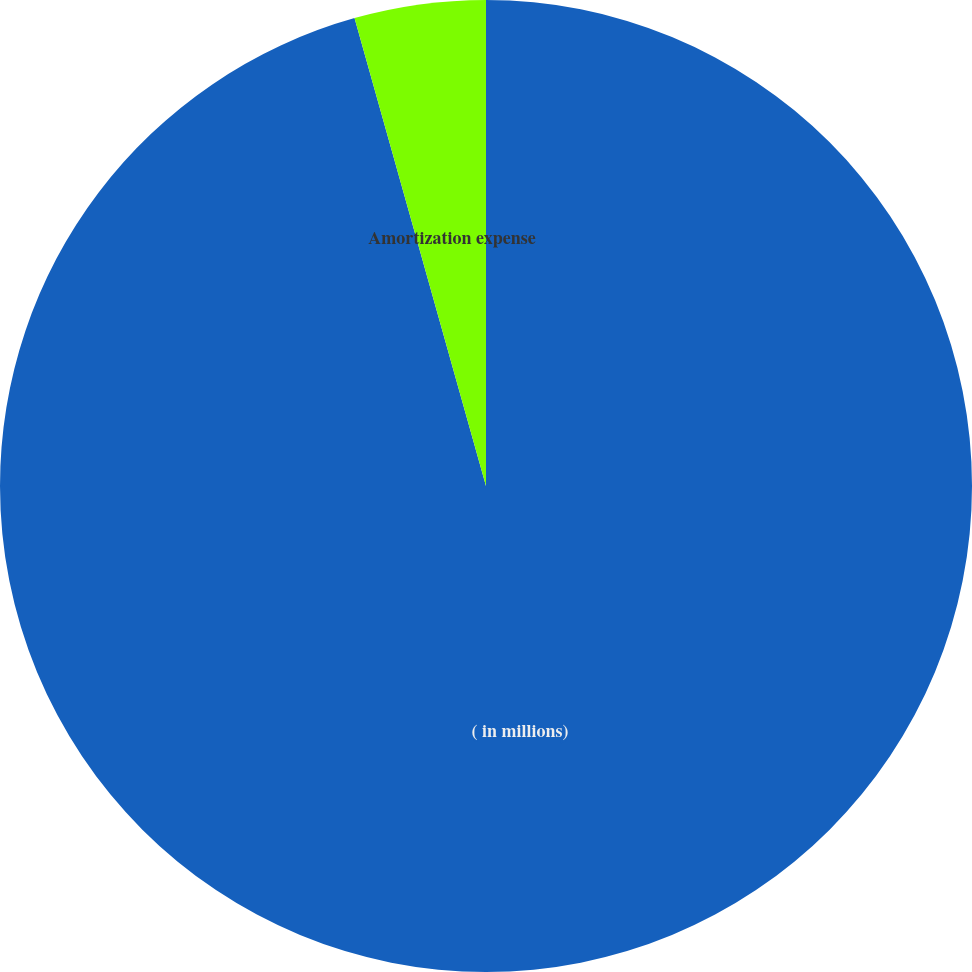Convert chart. <chart><loc_0><loc_0><loc_500><loc_500><pie_chart><fcel>( in millions)<fcel>Amortization expense<nl><fcel>95.64%<fcel>4.36%<nl></chart> 